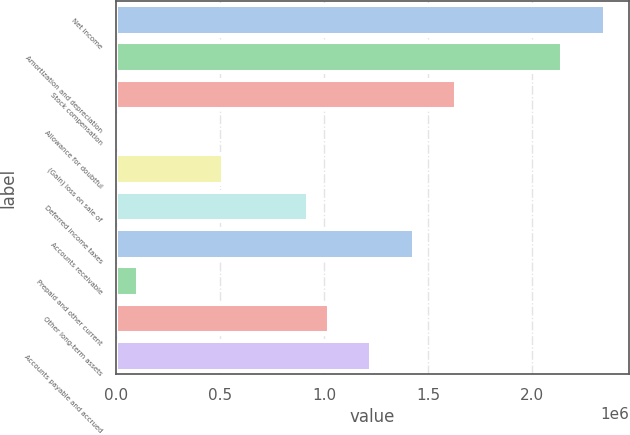Convert chart to OTSL. <chart><loc_0><loc_0><loc_500><loc_500><bar_chart><fcel>Net income<fcel>Amortization and depreciation<fcel>Stock compensation<fcel>Allowance for doubtful<fcel>(Gain) loss on sale of<fcel>Deferred income taxes<fcel>Accounts receivable<fcel>Prepaid and other current<fcel>Other long-term assets<fcel>Accounts payable and accrued<nl><fcel>2.34999e+06<fcel>2.14575e+06<fcel>1.63516e+06<fcel>1250<fcel>511846<fcel>920322<fcel>1.43092e+06<fcel>103369<fcel>1.02244e+06<fcel>1.22668e+06<nl></chart> 